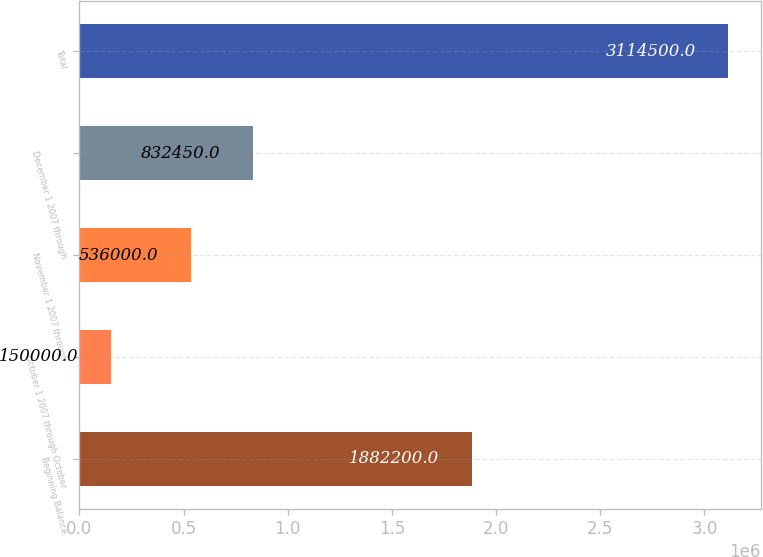<chart> <loc_0><loc_0><loc_500><loc_500><bar_chart><fcel>Beginning Balance<fcel>October 1 2007 through October<fcel>November 1 2007 through<fcel>December 1 2007 through<fcel>Total<nl><fcel>1.8822e+06<fcel>150000<fcel>536000<fcel>832450<fcel>3.1145e+06<nl></chart> 